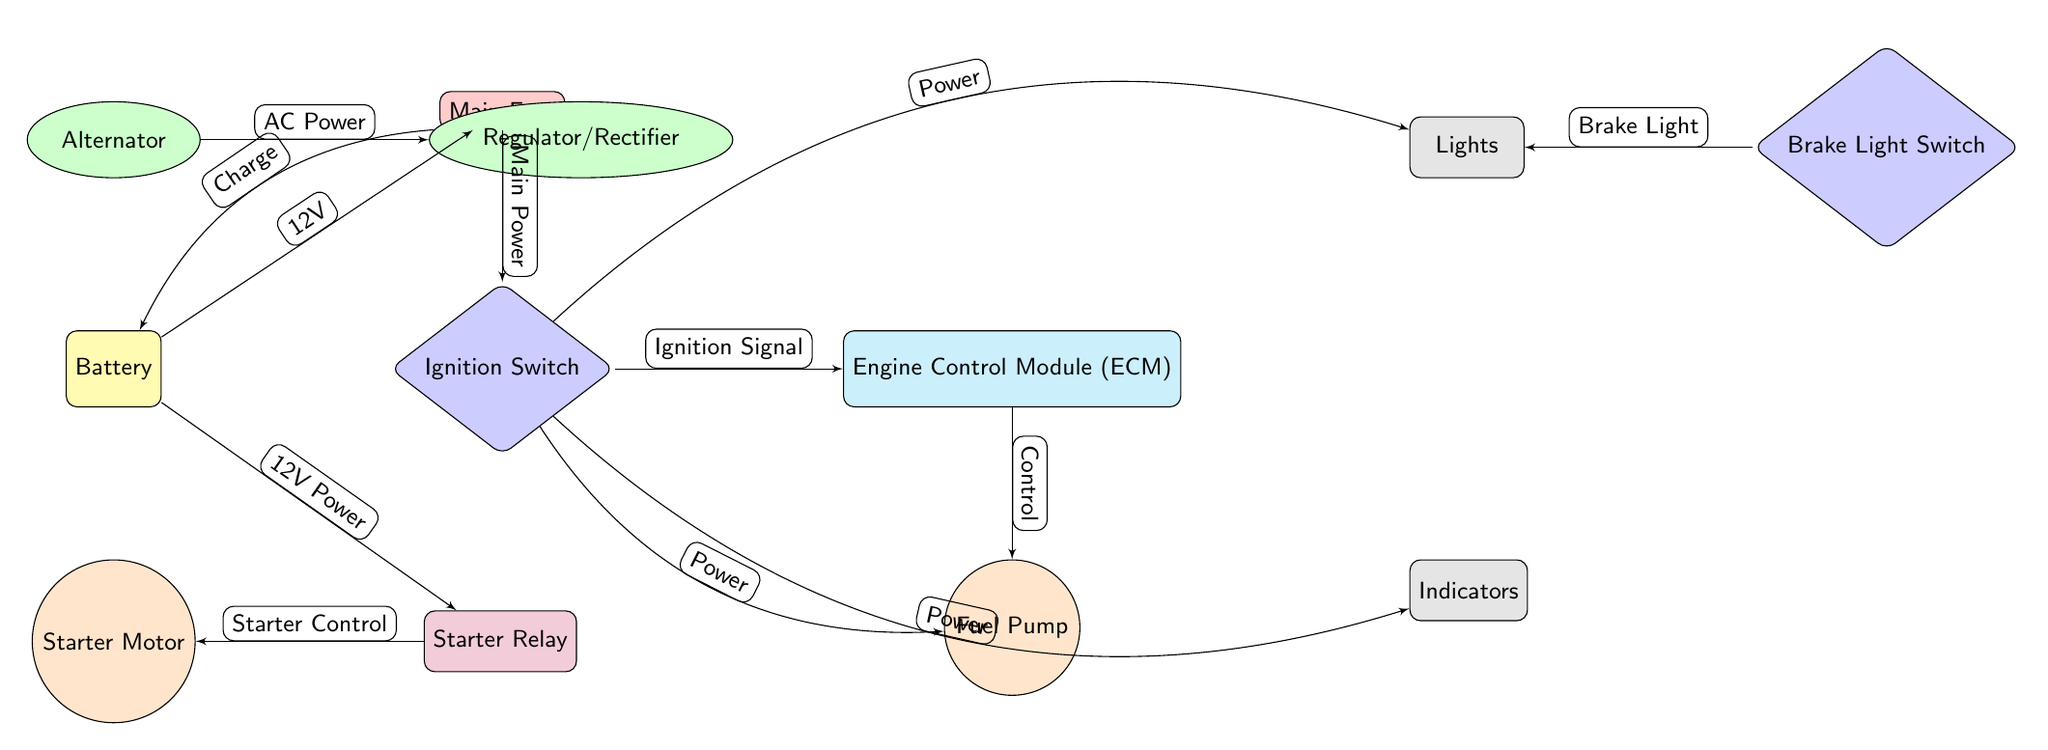What is the voltage supplied by the battery? The diagram indicates that the battery supplies 12V, as labeled on the edge connecting the battery to the main fuse.
Answer: 12V How many circuits are highlighted in the diagram? The diagram shows three circuits: the lights, indicators, and fuel pump, indicated as separate nodes branching from the engine control module.
Answer: 3 What is the relationship between the ignition switch and the engine control module? The edge between the ignition switch and engine control module shows "Ignition Signal," meaning the ignition switch provides a control signal to the engine control module for operation.
Answer: Ignition Signal What component connects the alternator to the regulator/rectifier? The edge labeled "AC Power" indicates the direct connection between the alternator and regulator/rectifier components.
Answer: AC Power What type of component is the starter relay? The starter relay is classified as a "relay" component in the diagram, indicated by its shape and corresponding label.
Answer: Relay Which component does the brake light switch connect to? The brake light switch connects to the lights, as indicated by the labeled edge "Brake Light."
Answer: Lights What is the first component in the electrical flow from the battery? The first component in the electrical flow from the battery is the main fuse, connected directly to the battery with the label "Main Power."
Answer: Main Fuse How does the fuel pump receive power? The fuel pump receives power from both the ignition switch and the engine control module, as indicated by the multiple connections in the diagram labeled "Power" and "Control."
Answer: Ignition Switch, Engine Control Module What component is positioned directly above the battery in the diagram? Directly above the battery is the alternator, which is clearly marked in the diagram.
Answer: Alternator 